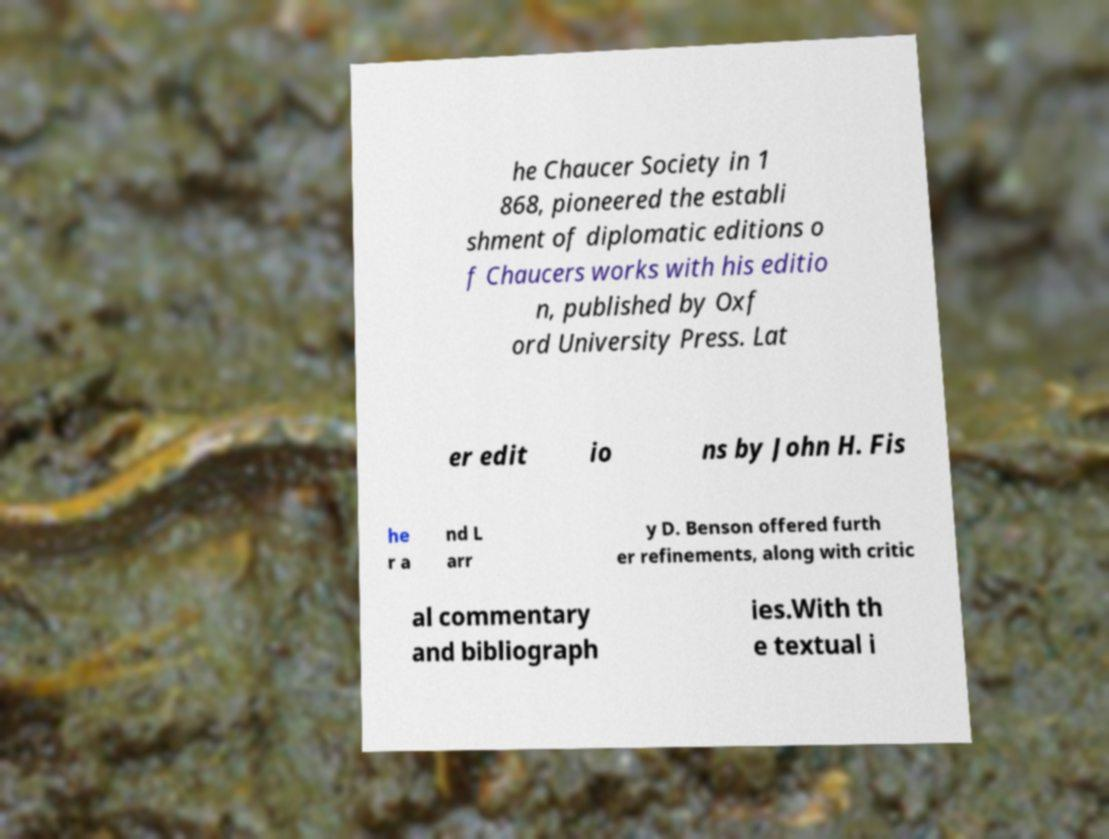Could you assist in decoding the text presented in this image and type it out clearly? he Chaucer Society in 1 868, pioneered the establi shment of diplomatic editions o f Chaucers works with his editio n, published by Oxf ord University Press. Lat er edit io ns by John H. Fis he r a nd L arr y D. Benson offered furth er refinements, along with critic al commentary and bibliograph ies.With th e textual i 